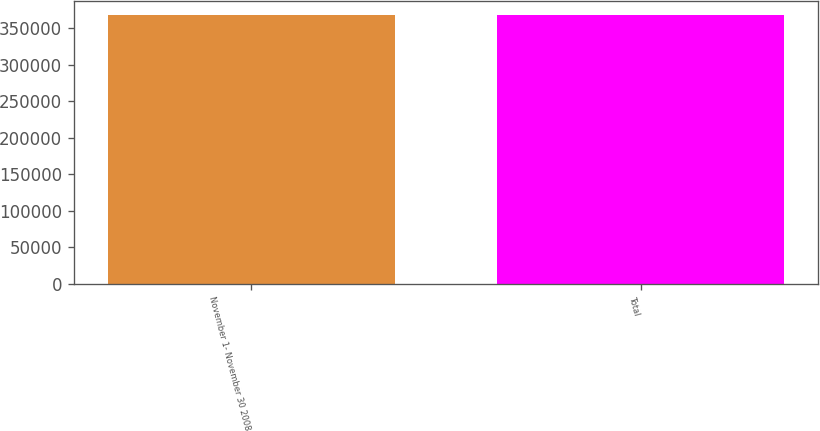<chart> <loc_0><loc_0><loc_500><loc_500><bar_chart><fcel>November 1- November 30 2008<fcel>Total<nl><fcel>368406<fcel>368406<nl></chart> 